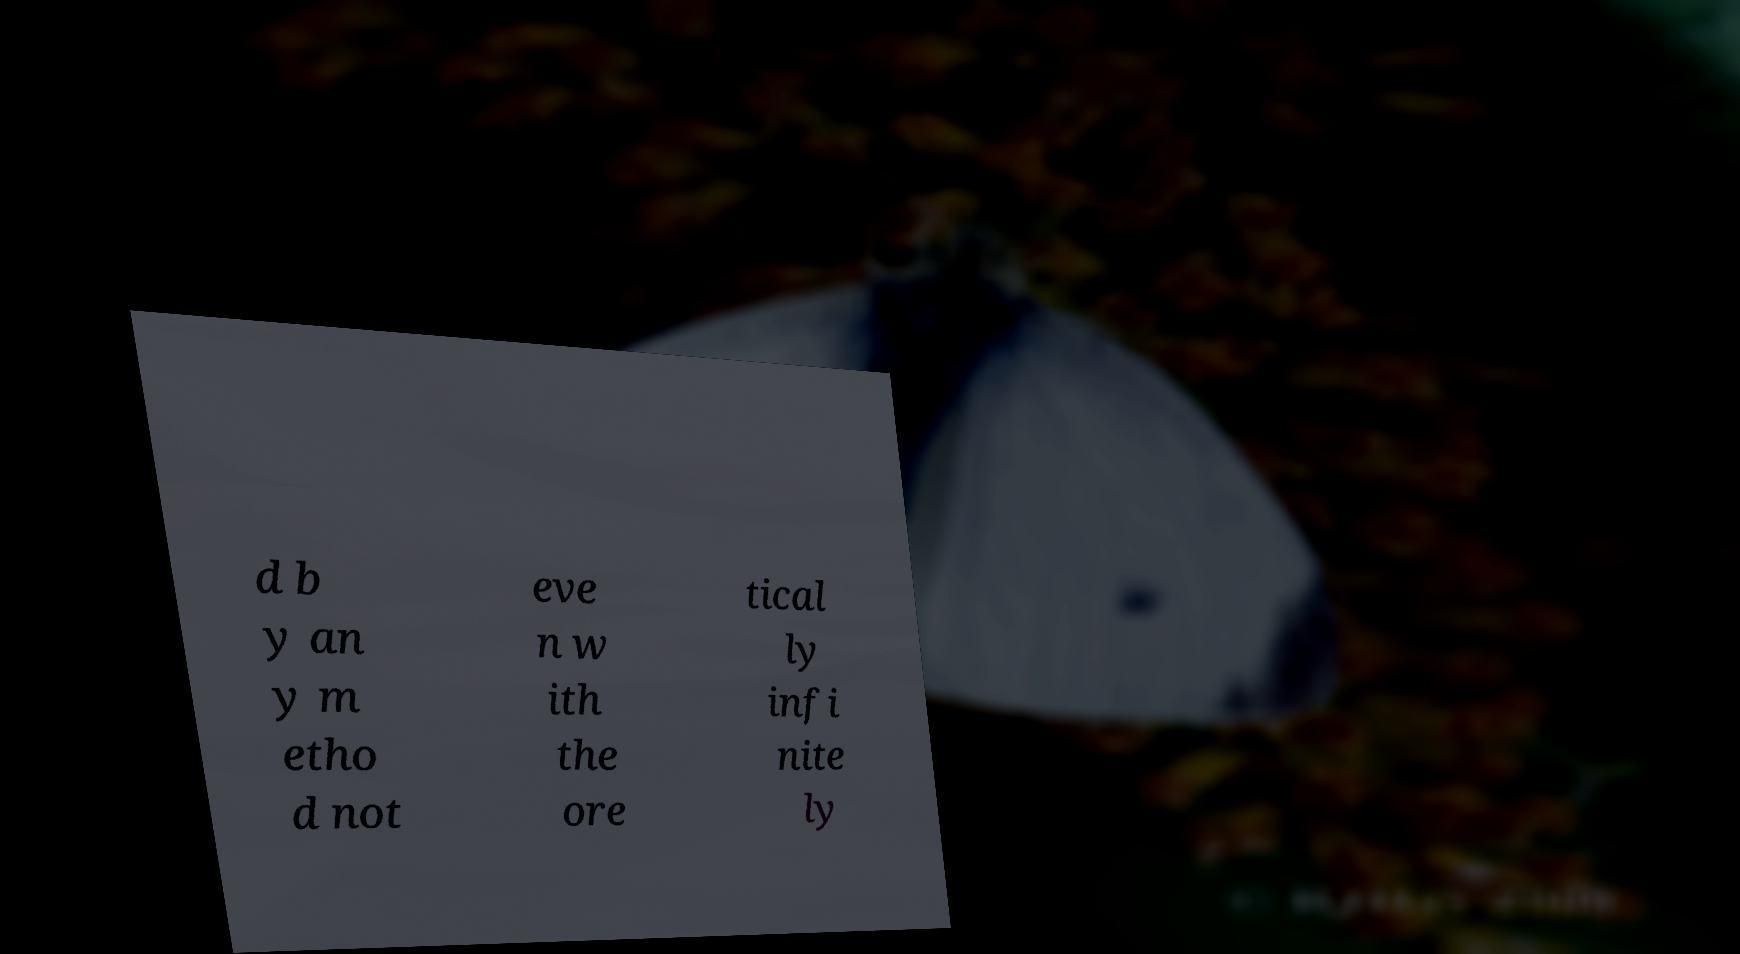For documentation purposes, I need the text within this image transcribed. Could you provide that? d b y an y m etho d not eve n w ith the ore tical ly infi nite ly 